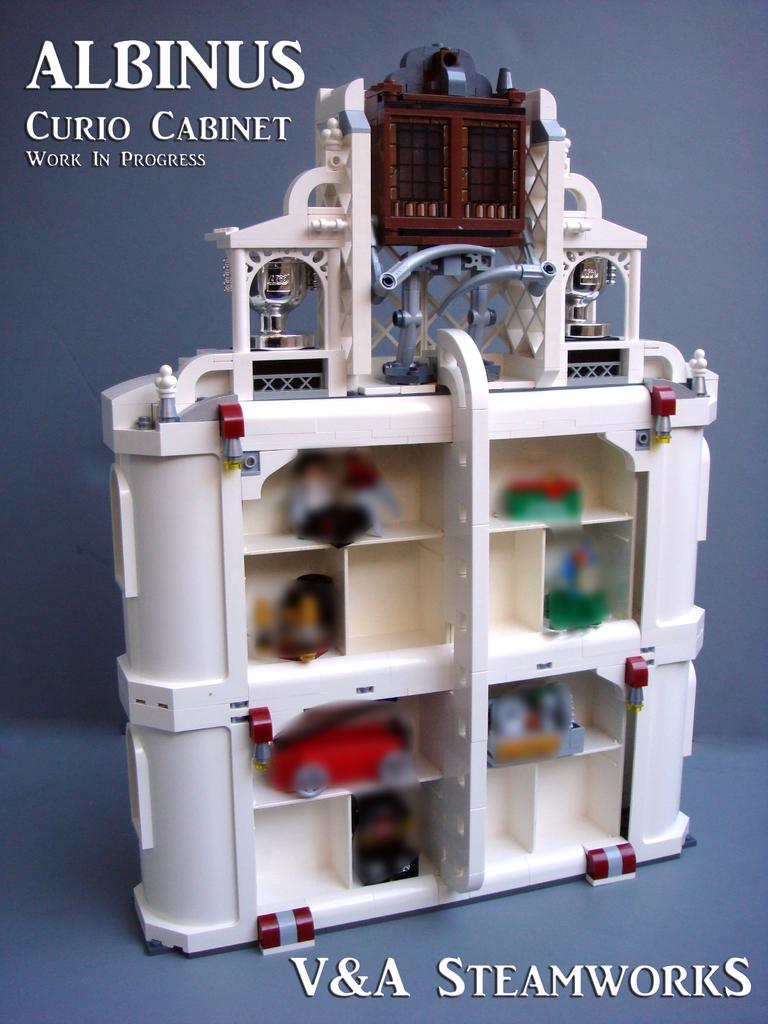<image>
Summarize the visual content of the image. A cute toy for little kids, with cars and accessories from Albinus. 